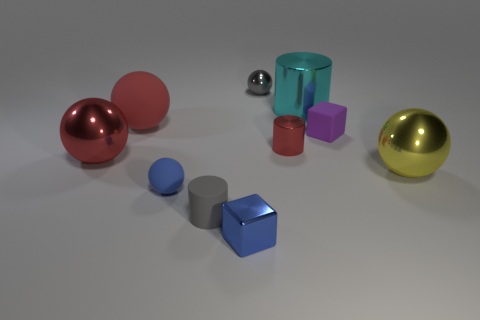Subtract all yellow spheres. How many spheres are left? 4 Subtract all tiny blue balls. How many balls are left? 4 Subtract all cyan spheres. Subtract all brown cylinders. How many spheres are left? 5 Subtract all cylinders. How many objects are left? 7 Subtract all yellow metal objects. Subtract all matte objects. How many objects are left? 5 Add 8 tiny blue blocks. How many tiny blue blocks are left? 9 Add 9 yellow metal things. How many yellow metal things exist? 10 Subtract 0 red blocks. How many objects are left? 10 